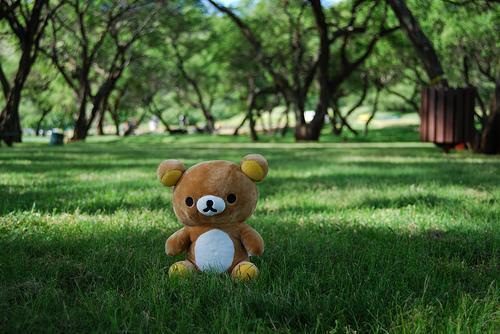How many people on motorcycles are facing this way?
Give a very brief answer. 0. 